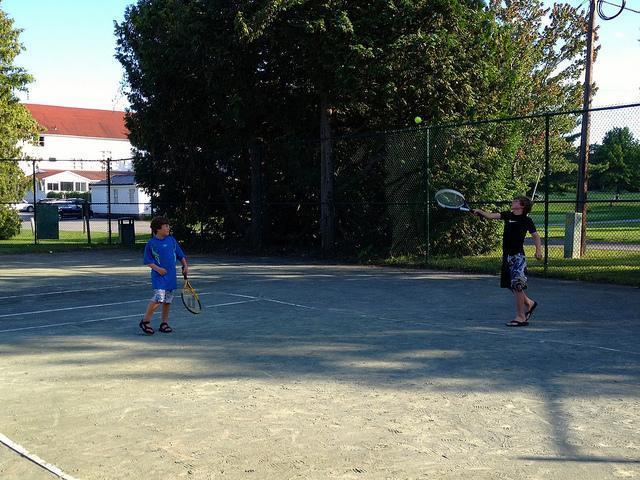How many kids are wearing sandals?
Give a very brief answer. 2. How many people are in the picture?
Give a very brief answer. 2. 